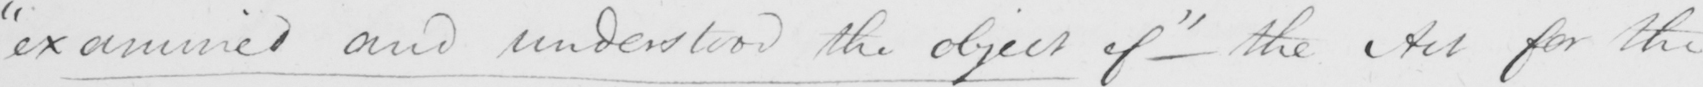What text is written in this handwritten line? " examined and understood the object of "  the Act for the 